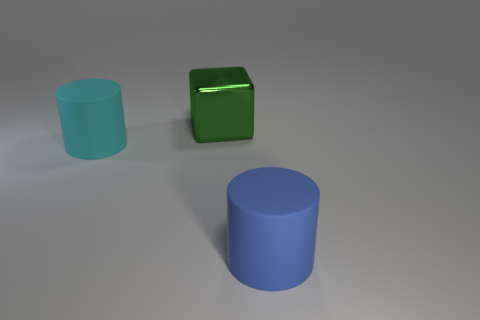There is a cylinder that is to the right of the rubber cylinder that is left of the green metallic cube; are there any big blue rubber cylinders in front of it?
Offer a very short reply. No. Is the size of the green metallic thing the same as the cyan rubber object?
Give a very brief answer. Yes. Are there the same number of large blue rubber cylinders right of the large green block and large green blocks that are right of the big blue cylinder?
Offer a terse response. No. There is a cyan object on the left side of the green metallic thing; what is its shape?
Your answer should be very brief. Cylinder. What is the shape of the green metal object that is the same size as the cyan cylinder?
Provide a short and direct response. Cube. The big thing that is behind the big cylinder that is left of the thing behind the cyan cylinder is what color?
Make the answer very short. Green. Is the blue object the same shape as the cyan matte object?
Your answer should be very brief. Yes. Are there the same number of metallic objects that are in front of the green metal object and tiny gray things?
Provide a succinct answer. Yes. How many other objects are the same material as the large green block?
Give a very brief answer. 0. How many objects are either large things that are behind the blue rubber object or matte things to the right of the big cyan rubber cylinder?
Provide a succinct answer. 3. 